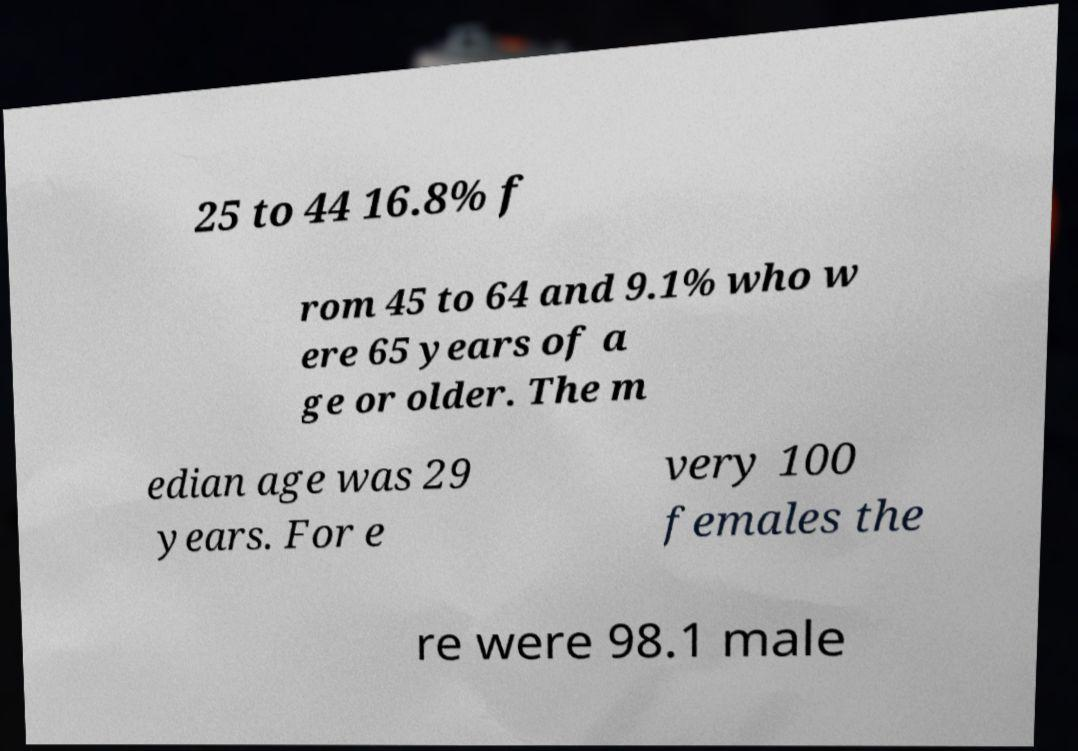Please read and relay the text visible in this image. What does it say? 25 to 44 16.8% f rom 45 to 64 and 9.1% who w ere 65 years of a ge or older. The m edian age was 29 years. For e very 100 females the re were 98.1 male 